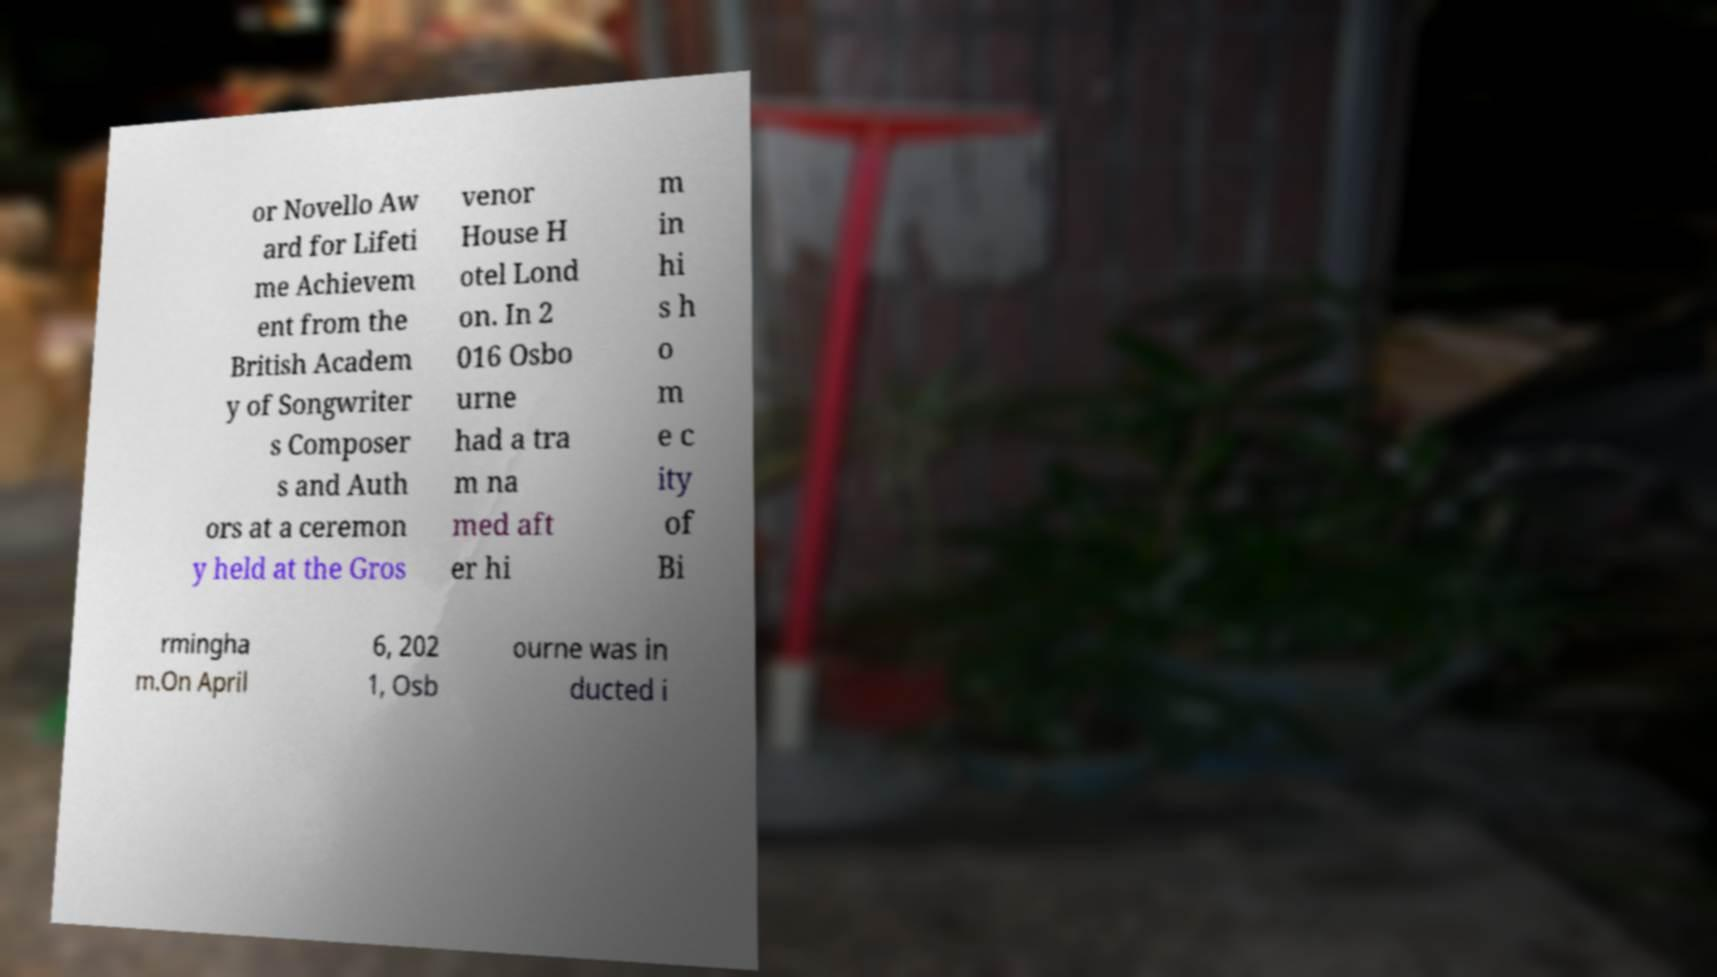Could you extract and type out the text from this image? or Novello Aw ard for Lifeti me Achievem ent from the British Academ y of Songwriter s Composer s and Auth ors at a ceremon y held at the Gros venor House H otel Lond on. In 2 016 Osbo urne had a tra m na med aft er hi m in hi s h o m e c ity of Bi rmingha m.On April 6, 202 1, Osb ourne was in ducted i 